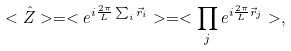Convert formula to latex. <formula><loc_0><loc_0><loc_500><loc_500>< \hat { Z } > = < e ^ { i \frac { 2 \pi } { L } \sum _ { i } \vec { r } _ { i } } > = < \prod _ { j } e ^ { i \frac { 2 \pi } { L } \vec { r } _ { j } } > ,</formula> 